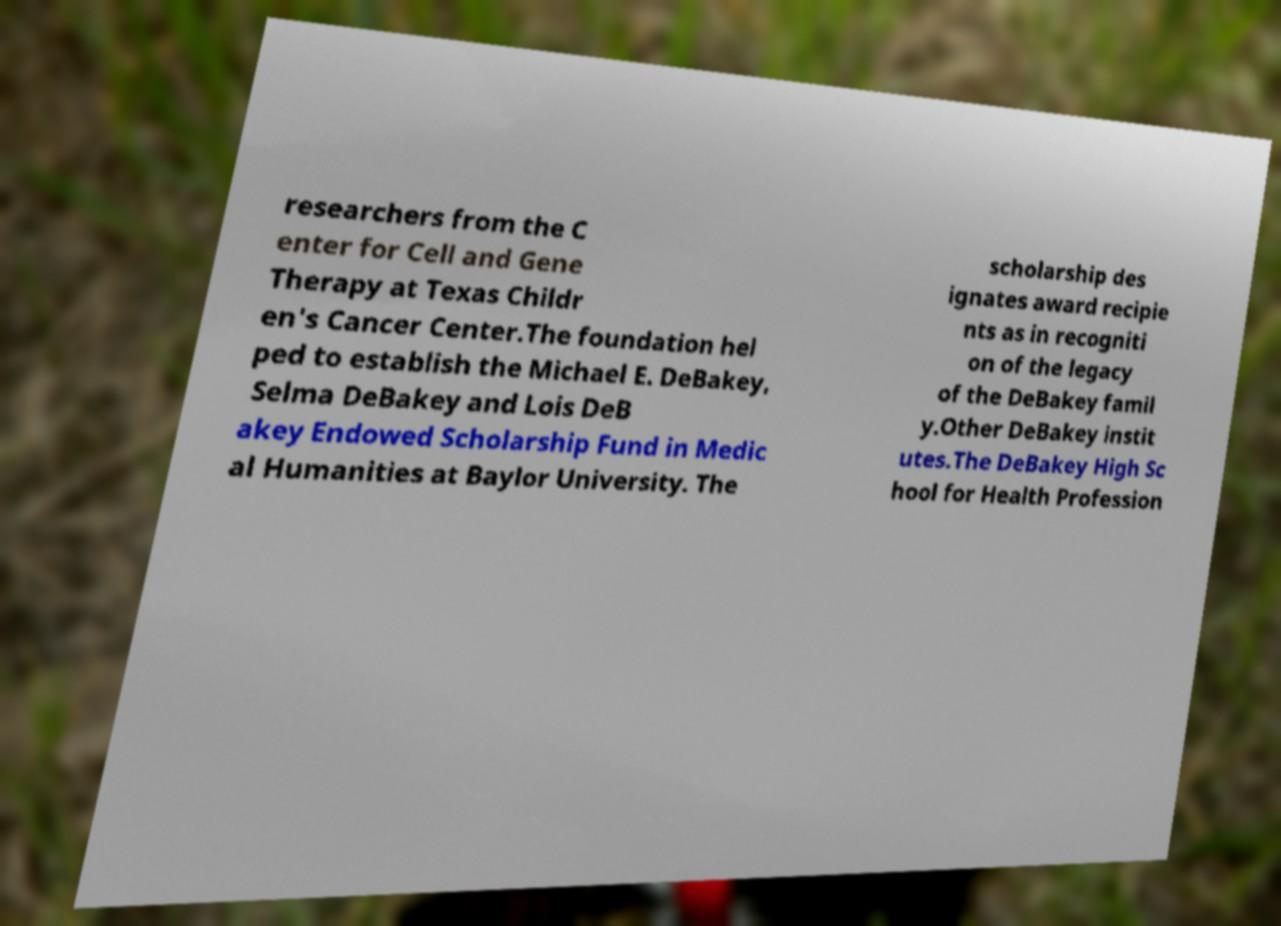Can you accurately transcribe the text from the provided image for me? researchers from the C enter for Cell and Gene Therapy at Texas Childr en's Cancer Center.The foundation hel ped to establish the Michael E. DeBakey, Selma DeBakey and Lois DeB akey Endowed Scholarship Fund in Medic al Humanities at Baylor University. The scholarship des ignates award recipie nts as in recogniti on of the legacy of the DeBakey famil y.Other DeBakey instit utes.The DeBakey High Sc hool for Health Profession 